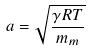Convert formula to latex. <formula><loc_0><loc_0><loc_500><loc_500>a = \sqrt { \frac { \gamma R T } { m _ { m } } }</formula> 